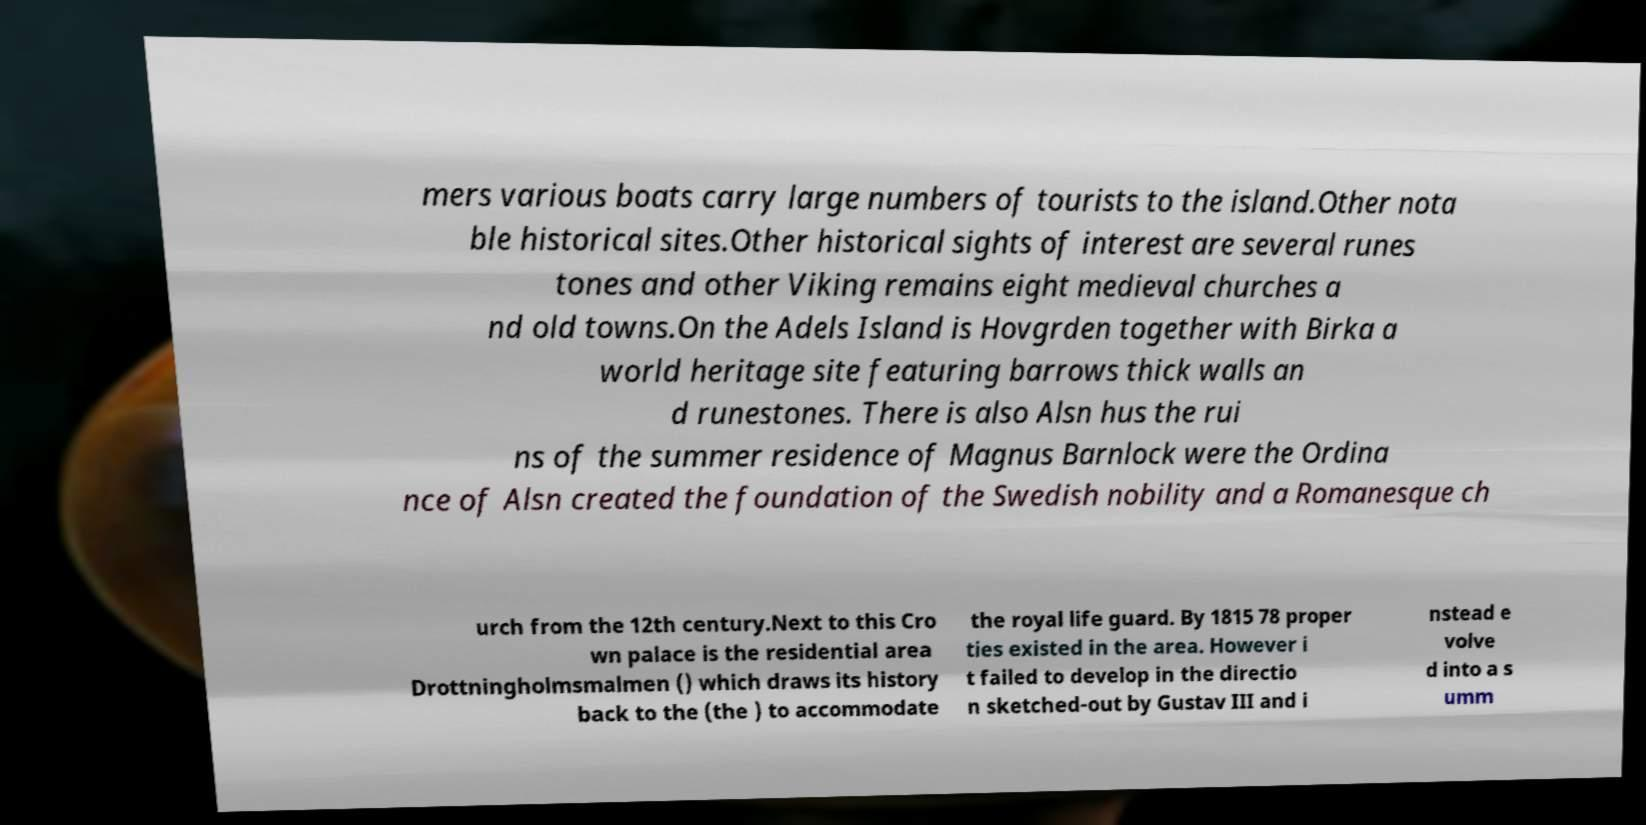Can you accurately transcribe the text from the provided image for me? mers various boats carry large numbers of tourists to the island.Other nota ble historical sites.Other historical sights of interest are several runes tones and other Viking remains eight medieval churches a nd old towns.On the Adels Island is Hovgrden together with Birka a world heritage site featuring barrows thick walls an d runestones. There is also Alsn hus the rui ns of the summer residence of Magnus Barnlock were the Ordina nce of Alsn created the foundation of the Swedish nobility and a Romanesque ch urch from the 12th century.Next to this Cro wn palace is the residential area Drottningholmsmalmen () which draws its history back to the (the ) to accommodate the royal life guard. By 1815 78 proper ties existed in the area. However i t failed to develop in the directio n sketched-out by Gustav III and i nstead e volve d into a s umm 